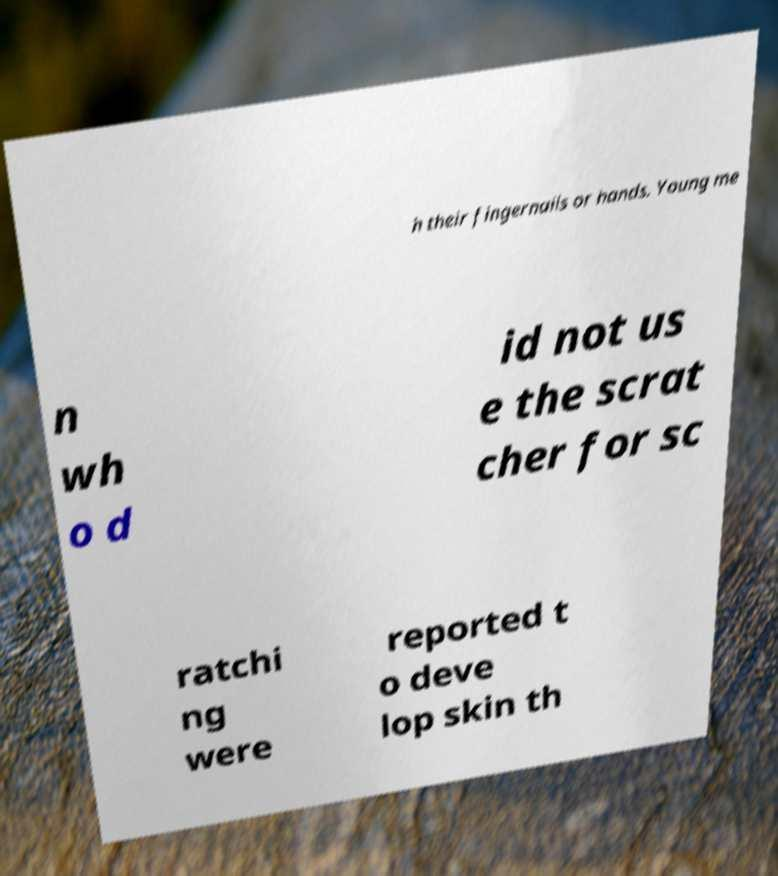For documentation purposes, I need the text within this image transcribed. Could you provide that? h their fingernails or hands. Young me n wh o d id not us e the scrat cher for sc ratchi ng were reported t o deve lop skin th 